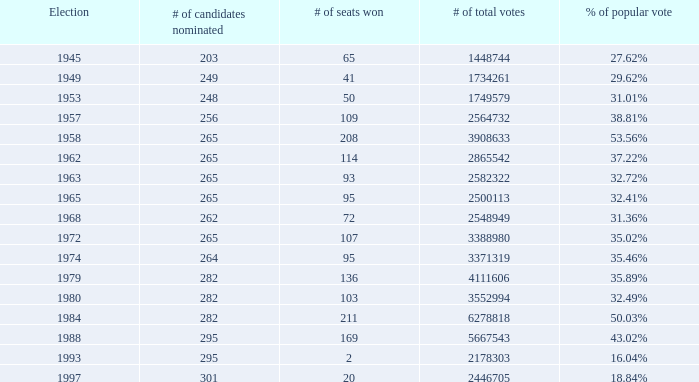I'm looking to parse the entire table for insights. Could you assist me with that? {'header': ['Election', '# of candidates nominated', '# of seats won', '# of total votes', '% of popular vote'], 'rows': [['1945', '203', '65', '1448744', '27.62%'], ['1949', '249', '41', '1734261', '29.62%'], ['1953', '248', '50', '1749579', '31.01%'], ['1957', '256', '109', '2564732', '38.81%'], ['1958', '265', '208', '3908633', '53.56%'], ['1962', '265', '114', '2865542', '37.22%'], ['1963', '265', '93', '2582322', '32.72%'], ['1965', '265', '95', '2500113', '32.41%'], ['1968', '262', '72', '2548949', '31.36%'], ['1972', '265', '107', '3388980', '35.02%'], ['1974', '264', '95', '3371319', '35.46%'], ['1979', '282', '136', '4111606', '35.89%'], ['1980', '282', '103', '3552994', '32.49%'], ['1984', '282', '211', '6278818', '50.03%'], ['1988', '295', '169', '5667543', '43.02%'], ['1993', '295', '2', '2178303', '16.04%'], ['1997', '301', '20', '2446705', '18.84%']]} What is the # of seats one for the election in 1974? 95.0. 